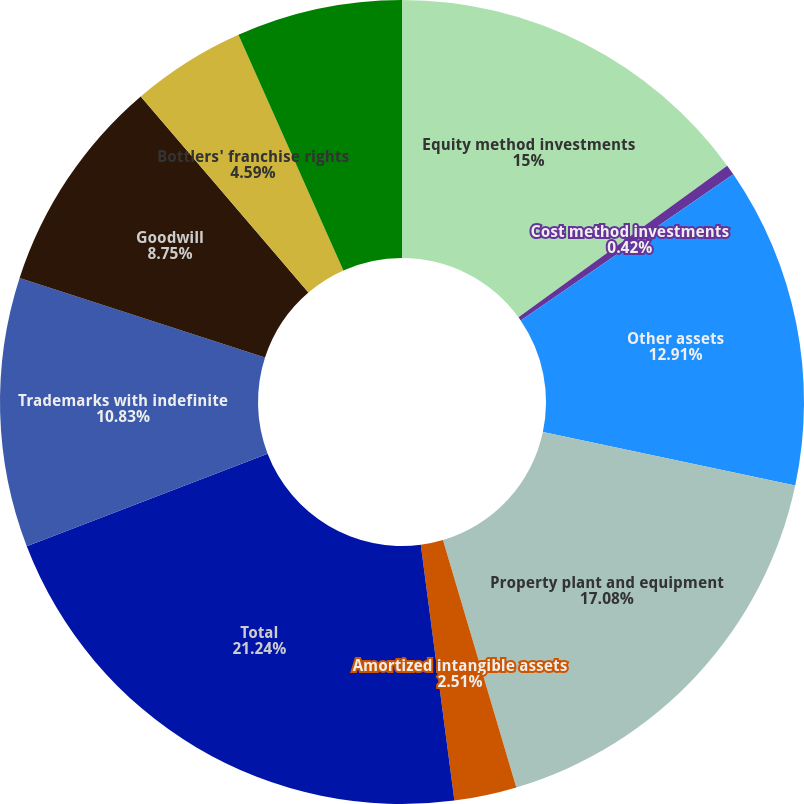Convert chart to OTSL. <chart><loc_0><loc_0><loc_500><loc_500><pie_chart><fcel>Equity method investments<fcel>Cost method investments<fcel>Other assets<fcel>Property plant and equipment<fcel>Amortized intangible assets<fcel>Total<fcel>Trademarks with indefinite<fcel>Goodwill<fcel>Bottlers' franchise rights<fcel>Other intangible assets not<nl><fcel>15.0%<fcel>0.42%<fcel>12.91%<fcel>17.08%<fcel>2.51%<fcel>21.24%<fcel>10.83%<fcel>8.75%<fcel>4.59%<fcel>6.67%<nl></chart> 